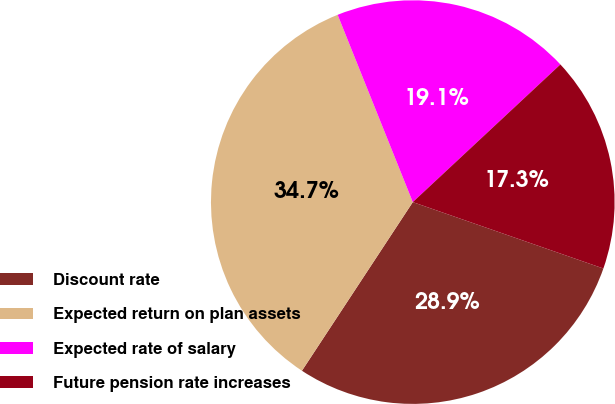Convert chart. <chart><loc_0><loc_0><loc_500><loc_500><pie_chart><fcel>Discount rate<fcel>Expected return on plan assets<fcel>Expected rate of salary<fcel>Future pension rate increases<nl><fcel>28.92%<fcel>34.67%<fcel>19.13%<fcel>17.28%<nl></chart> 